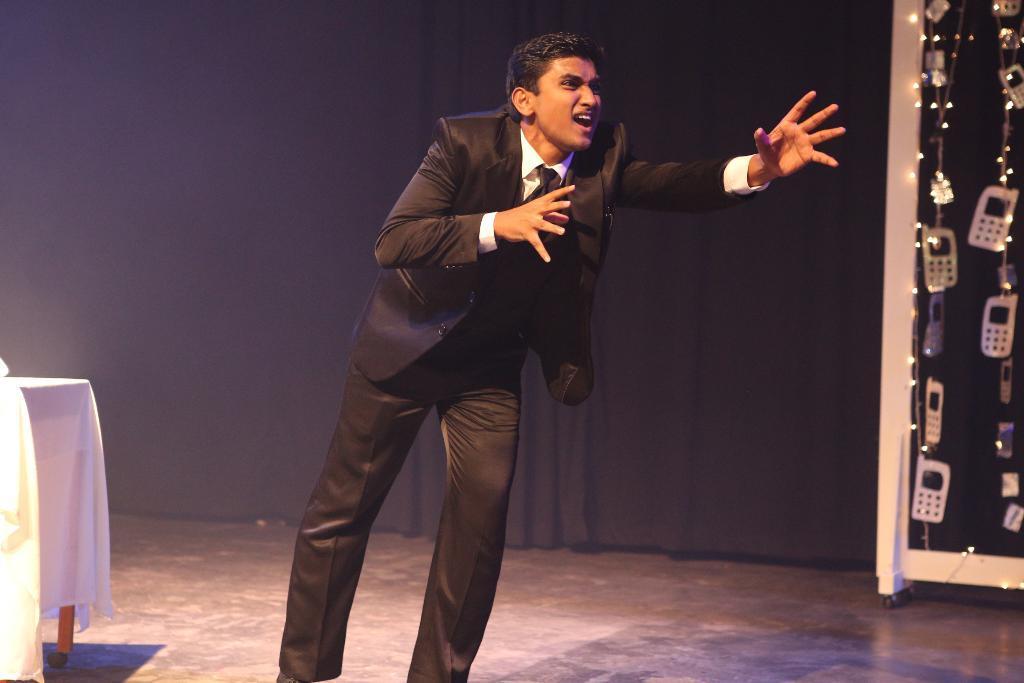Describe this image in one or two sentences. In this image I can see a man is standing in the front and I can see he is wearing black and white colour formal dress. On the right side of this image I can see number of white colour things and lights. On the left side I can see a table and on it I can see a white colour tablecloth. In the background I can see black colour curtain. 